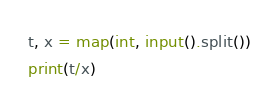Convert code to text. <code><loc_0><loc_0><loc_500><loc_500><_Python_>t, x = map(int, input().split())
print(t/x)</code> 